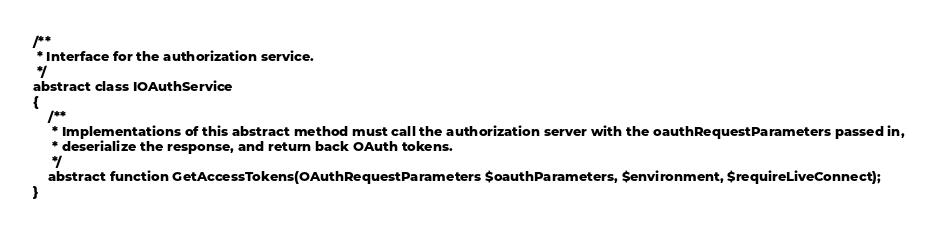<code> <loc_0><loc_0><loc_500><loc_500><_PHP_>
/** 
 * Interface for the authorization service.
 */
abstract class IOAuthService
{
    /** 
     * Implementations of this abstract method must call the authorization server with the oauthRequestParameters passed in, 
     * deserialize the response, and return back OAuth tokens.
     */
    abstract function GetAccessTokens(OAuthRequestParameters $oauthParameters, $environment, $requireLiveConnect);
}
</code> 